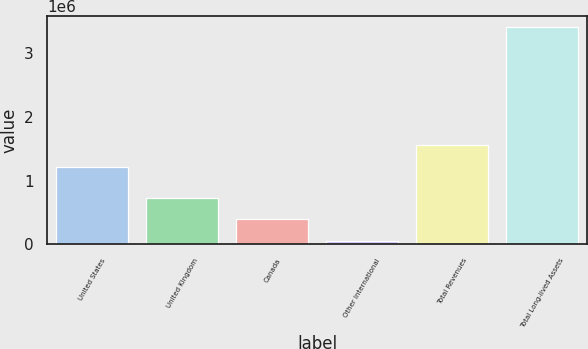<chart> <loc_0><loc_0><loc_500><loc_500><bar_chart><fcel>United States<fcel>United Kingdom<fcel>Canada<fcel>Other International<fcel>Total Revenues<fcel>Total Long-lived Assets<nl><fcel>1.21567e+06<fcel>725970<fcel>389151<fcel>52333<fcel>1.55249e+06<fcel>3.42052e+06<nl></chart> 